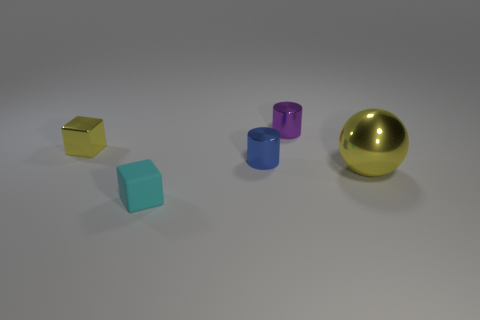Are there any other things that have the same material as the small cyan object?
Your response must be concise. No. What is the material of the large object that is the same color as the small shiny block?
Make the answer very short. Metal. Is there any other thing that has the same size as the shiny sphere?
Provide a succinct answer. No. There is a yellow thing that is on the left side of the large yellow shiny thing; is its size the same as the object on the right side of the small purple metal object?
Ensure brevity in your answer.  No. What color is the other thing that is the same shape as the tiny blue thing?
Ensure brevity in your answer.  Purple. Is there anything else that has the same shape as the big metallic thing?
Provide a succinct answer. No. Is the number of tiny blocks that are in front of the small blue metal cylinder greater than the number of yellow things behind the small purple object?
Offer a very short reply. Yes. There is a blue shiny cylinder that is behind the block that is in front of the yellow shiny object on the left side of the big thing; what size is it?
Ensure brevity in your answer.  Small. Does the purple cylinder have the same material as the blue thing to the left of the large yellow metallic sphere?
Your answer should be compact. Yes. Do the tiny rubber object and the tiny yellow metallic object have the same shape?
Offer a terse response. Yes. 